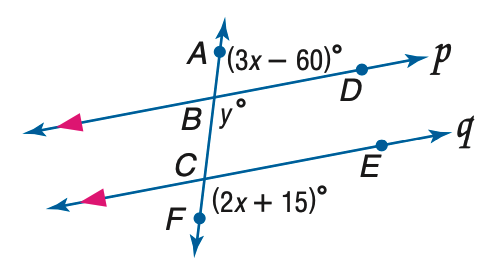Answer the mathemtical geometry problem and directly provide the correct option letter.
Question: Refer to the figure at the right. Find the value of m \angle B C E if p \parallel q.
Choices: A: 75 B: 80 C: 85 D: 605 A 